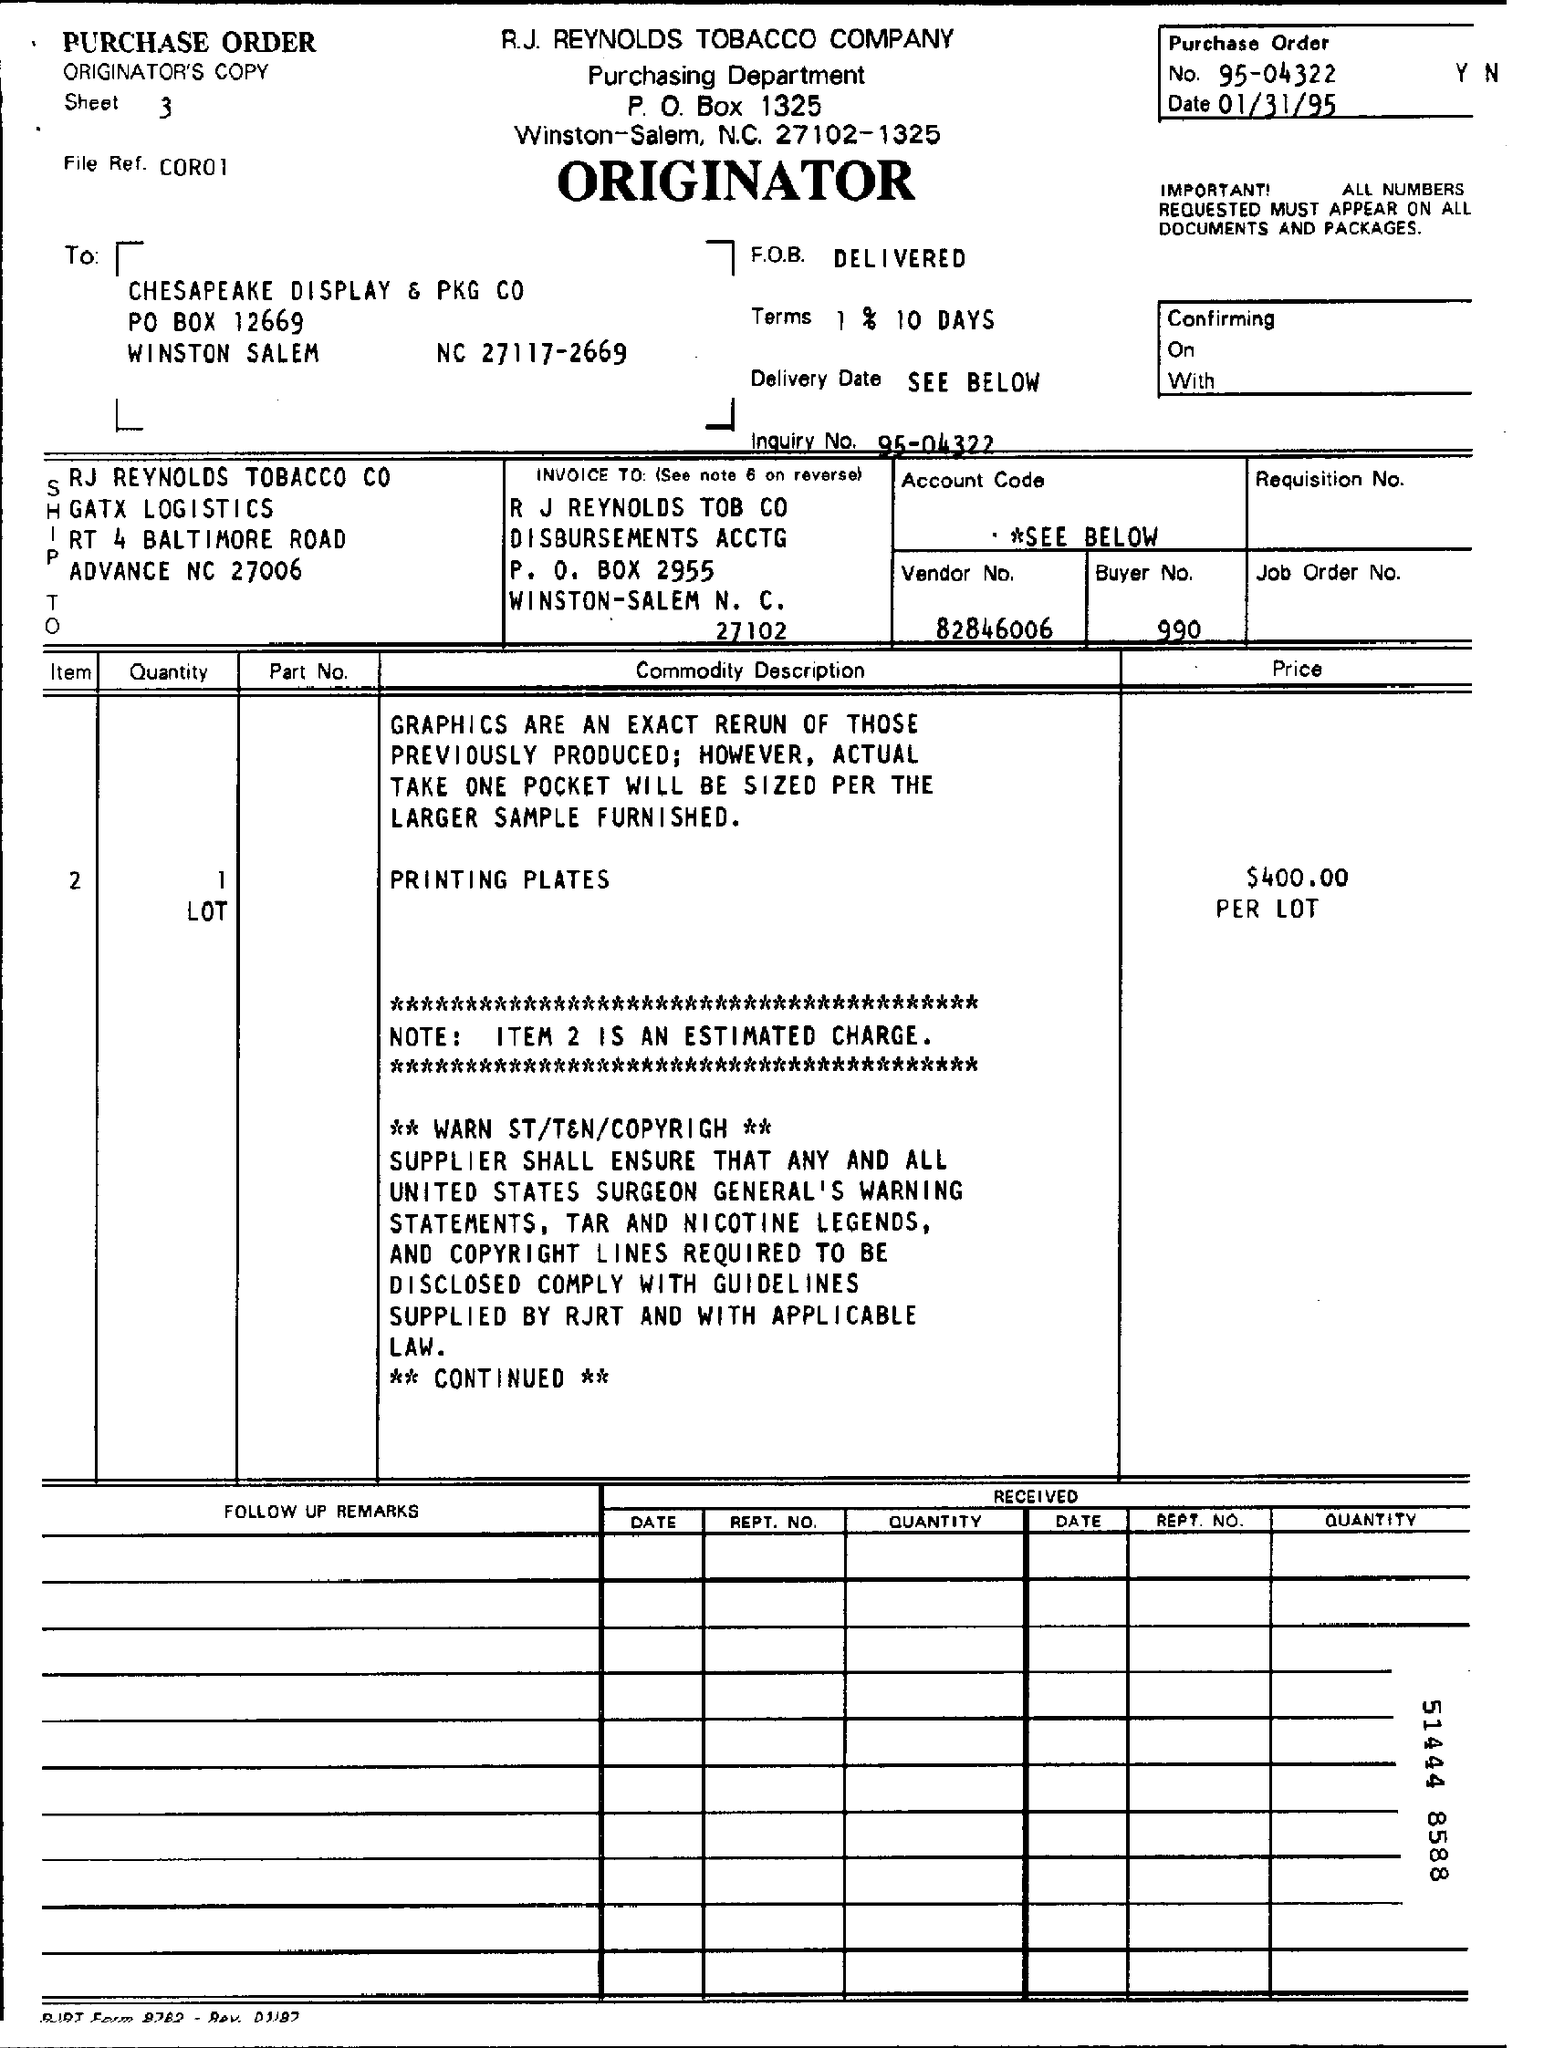Draw attention to some important aspects in this diagram. A purchase order number is 95-04322. It is mentioned that 1% is applicable for 10 days. Note" refers to Item 2, which is an estimated charge. The price per lot is $400.00. 